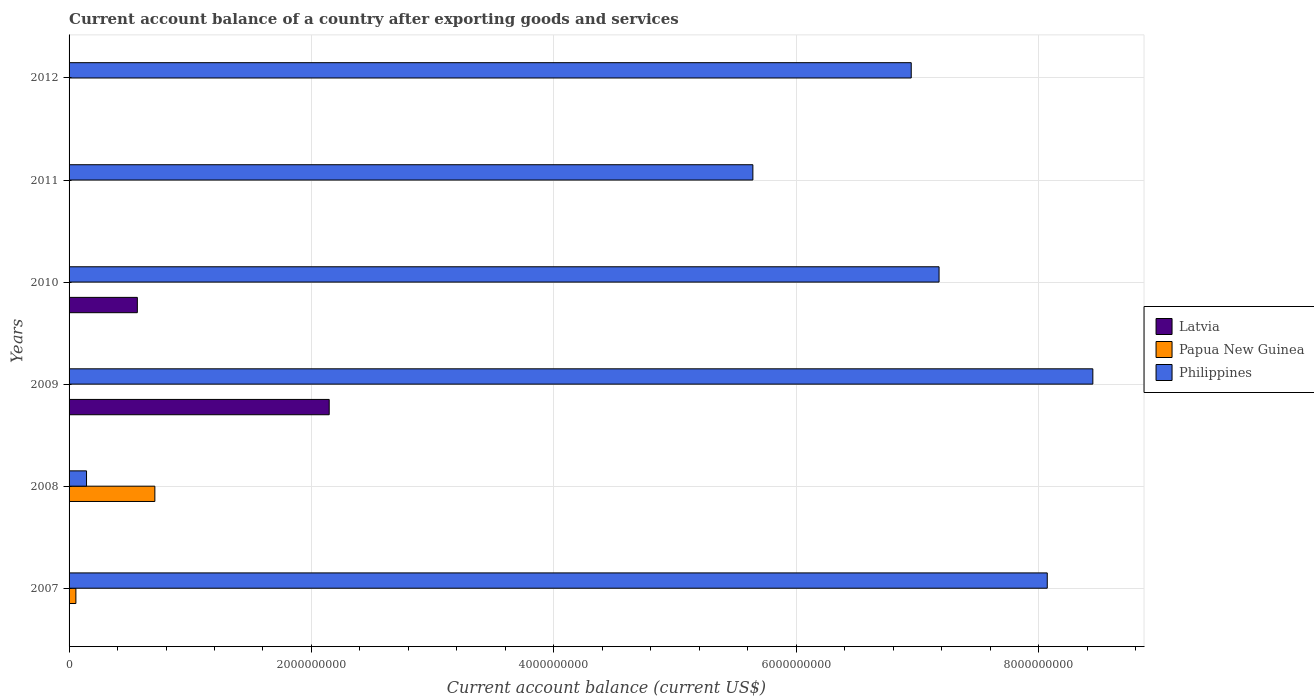Are the number of bars per tick equal to the number of legend labels?
Offer a terse response. No. Are the number of bars on each tick of the Y-axis equal?
Make the answer very short. No. How many bars are there on the 1st tick from the top?
Ensure brevity in your answer.  1. What is the label of the 6th group of bars from the top?
Give a very brief answer. 2007. In how many cases, is the number of bars for a given year not equal to the number of legend labels?
Make the answer very short. 6. What is the account balance in Papua New Guinea in 2007?
Offer a terse response. 5.63e+07. Across all years, what is the maximum account balance in Philippines?
Ensure brevity in your answer.  8.45e+09. What is the total account balance in Philippines in the graph?
Give a very brief answer. 3.64e+1. What is the difference between the account balance in Philippines in 2010 and that in 2012?
Your answer should be compact. 2.30e+08. What is the difference between the account balance in Philippines in 2009 and the account balance in Latvia in 2008?
Offer a very short reply. 8.45e+09. What is the average account balance in Latvia per year?
Give a very brief answer. 4.52e+08. In the year 2009, what is the difference between the account balance in Philippines and account balance in Latvia?
Ensure brevity in your answer.  6.30e+09. In how many years, is the account balance in Papua New Guinea greater than 4800000000 US$?
Your response must be concise. 0. What is the ratio of the account balance in Philippines in 2011 to that in 2012?
Your answer should be compact. 0.81. Is the account balance in Philippines in 2010 less than that in 2011?
Ensure brevity in your answer.  No. What is the difference between the highest and the lowest account balance in Latvia?
Your answer should be very brief. 2.15e+09. How many bars are there?
Make the answer very short. 10. Are all the bars in the graph horizontal?
Keep it short and to the point. Yes. What is the difference between two consecutive major ticks on the X-axis?
Ensure brevity in your answer.  2.00e+09. Does the graph contain any zero values?
Keep it short and to the point. Yes. Where does the legend appear in the graph?
Offer a terse response. Center right. How are the legend labels stacked?
Your response must be concise. Vertical. What is the title of the graph?
Make the answer very short. Current account balance of a country after exporting goods and services. Does "Solomon Islands" appear as one of the legend labels in the graph?
Your answer should be very brief. No. What is the label or title of the X-axis?
Provide a succinct answer. Current account balance (current US$). What is the Current account balance (current US$) of Latvia in 2007?
Ensure brevity in your answer.  0. What is the Current account balance (current US$) in Papua New Guinea in 2007?
Your answer should be very brief. 5.63e+07. What is the Current account balance (current US$) in Philippines in 2007?
Your answer should be compact. 8.07e+09. What is the Current account balance (current US$) of Latvia in 2008?
Make the answer very short. 0. What is the Current account balance (current US$) of Papua New Guinea in 2008?
Offer a terse response. 7.08e+08. What is the Current account balance (current US$) of Philippines in 2008?
Ensure brevity in your answer.  1.44e+08. What is the Current account balance (current US$) in Latvia in 2009?
Provide a succinct answer. 2.15e+09. What is the Current account balance (current US$) of Philippines in 2009?
Your answer should be very brief. 8.45e+09. What is the Current account balance (current US$) of Latvia in 2010?
Provide a short and direct response. 5.63e+08. What is the Current account balance (current US$) of Papua New Guinea in 2010?
Give a very brief answer. 0. What is the Current account balance (current US$) in Philippines in 2010?
Provide a succinct answer. 7.18e+09. What is the Current account balance (current US$) of Philippines in 2011?
Your answer should be compact. 5.64e+09. What is the Current account balance (current US$) of Latvia in 2012?
Provide a succinct answer. 0. What is the Current account balance (current US$) of Papua New Guinea in 2012?
Offer a terse response. 0. What is the Current account balance (current US$) in Philippines in 2012?
Give a very brief answer. 6.95e+09. Across all years, what is the maximum Current account balance (current US$) in Latvia?
Your response must be concise. 2.15e+09. Across all years, what is the maximum Current account balance (current US$) of Papua New Guinea?
Your response must be concise. 7.08e+08. Across all years, what is the maximum Current account balance (current US$) in Philippines?
Ensure brevity in your answer.  8.45e+09. Across all years, what is the minimum Current account balance (current US$) in Latvia?
Give a very brief answer. 0. Across all years, what is the minimum Current account balance (current US$) of Papua New Guinea?
Offer a terse response. 0. Across all years, what is the minimum Current account balance (current US$) in Philippines?
Keep it short and to the point. 1.44e+08. What is the total Current account balance (current US$) of Latvia in the graph?
Provide a succinct answer. 2.71e+09. What is the total Current account balance (current US$) in Papua New Guinea in the graph?
Offer a terse response. 7.64e+08. What is the total Current account balance (current US$) of Philippines in the graph?
Ensure brevity in your answer.  3.64e+1. What is the difference between the Current account balance (current US$) in Papua New Guinea in 2007 and that in 2008?
Your answer should be very brief. -6.52e+08. What is the difference between the Current account balance (current US$) in Philippines in 2007 and that in 2008?
Provide a short and direct response. 7.93e+09. What is the difference between the Current account balance (current US$) in Philippines in 2007 and that in 2009?
Your answer should be very brief. -3.76e+08. What is the difference between the Current account balance (current US$) in Philippines in 2007 and that in 2010?
Offer a terse response. 8.93e+08. What is the difference between the Current account balance (current US$) of Philippines in 2007 and that in 2011?
Offer a very short reply. 2.43e+09. What is the difference between the Current account balance (current US$) of Philippines in 2007 and that in 2012?
Provide a succinct answer. 1.12e+09. What is the difference between the Current account balance (current US$) of Philippines in 2008 and that in 2009?
Make the answer very short. -8.30e+09. What is the difference between the Current account balance (current US$) in Philippines in 2008 and that in 2010?
Your response must be concise. -7.04e+09. What is the difference between the Current account balance (current US$) in Philippines in 2008 and that in 2011?
Your response must be concise. -5.50e+09. What is the difference between the Current account balance (current US$) in Philippines in 2008 and that in 2012?
Offer a very short reply. -6.81e+09. What is the difference between the Current account balance (current US$) of Latvia in 2009 and that in 2010?
Offer a very short reply. 1.58e+09. What is the difference between the Current account balance (current US$) in Philippines in 2009 and that in 2010?
Give a very brief answer. 1.27e+09. What is the difference between the Current account balance (current US$) of Philippines in 2009 and that in 2011?
Provide a succinct answer. 2.81e+09. What is the difference between the Current account balance (current US$) in Philippines in 2009 and that in 2012?
Offer a very short reply. 1.50e+09. What is the difference between the Current account balance (current US$) of Philippines in 2010 and that in 2011?
Provide a succinct answer. 1.54e+09. What is the difference between the Current account balance (current US$) in Philippines in 2010 and that in 2012?
Ensure brevity in your answer.  2.30e+08. What is the difference between the Current account balance (current US$) in Philippines in 2011 and that in 2012?
Provide a short and direct response. -1.31e+09. What is the difference between the Current account balance (current US$) in Papua New Guinea in 2007 and the Current account balance (current US$) in Philippines in 2008?
Provide a succinct answer. -8.77e+07. What is the difference between the Current account balance (current US$) in Papua New Guinea in 2007 and the Current account balance (current US$) in Philippines in 2009?
Give a very brief answer. -8.39e+09. What is the difference between the Current account balance (current US$) in Papua New Guinea in 2007 and the Current account balance (current US$) in Philippines in 2010?
Your answer should be compact. -7.12e+09. What is the difference between the Current account balance (current US$) of Papua New Guinea in 2007 and the Current account balance (current US$) of Philippines in 2011?
Make the answer very short. -5.59e+09. What is the difference between the Current account balance (current US$) of Papua New Guinea in 2007 and the Current account balance (current US$) of Philippines in 2012?
Your response must be concise. -6.89e+09. What is the difference between the Current account balance (current US$) in Papua New Guinea in 2008 and the Current account balance (current US$) in Philippines in 2009?
Provide a succinct answer. -7.74e+09. What is the difference between the Current account balance (current US$) of Papua New Guinea in 2008 and the Current account balance (current US$) of Philippines in 2010?
Your response must be concise. -6.47e+09. What is the difference between the Current account balance (current US$) in Papua New Guinea in 2008 and the Current account balance (current US$) in Philippines in 2011?
Your answer should be compact. -4.93e+09. What is the difference between the Current account balance (current US$) in Papua New Guinea in 2008 and the Current account balance (current US$) in Philippines in 2012?
Make the answer very short. -6.24e+09. What is the difference between the Current account balance (current US$) of Latvia in 2009 and the Current account balance (current US$) of Philippines in 2010?
Offer a terse response. -5.03e+09. What is the difference between the Current account balance (current US$) in Latvia in 2009 and the Current account balance (current US$) in Philippines in 2011?
Make the answer very short. -3.50e+09. What is the difference between the Current account balance (current US$) in Latvia in 2009 and the Current account balance (current US$) in Philippines in 2012?
Your answer should be compact. -4.80e+09. What is the difference between the Current account balance (current US$) in Latvia in 2010 and the Current account balance (current US$) in Philippines in 2011?
Your answer should be very brief. -5.08e+09. What is the difference between the Current account balance (current US$) of Latvia in 2010 and the Current account balance (current US$) of Philippines in 2012?
Ensure brevity in your answer.  -6.39e+09. What is the average Current account balance (current US$) of Latvia per year?
Your answer should be compact. 4.52e+08. What is the average Current account balance (current US$) in Papua New Guinea per year?
Ensure brevity in your answer.  1.27e+08. What is the average Current account balance (current US$) in Philippines per year?
Provide a succinct answer. 6.07e+09. In the year 2007, what is the difference between the Current account balance (current US$) of Papua New Guinea and Current account balance (current US$) of Philippines?
Your response must be concise. -8.02e+09. In the year 2008, what is the difference between the Current account balance (current US$) of Papua New Guinea and Current account balance (current US$) of Philippines?
Give a very brief answer. 5.64e+08. In the year 2009, what is the difference between the Current account balance (current US$) of Latvia and Current account balance (current US$) of Philippines?
Your answer should be compact. -6.30e+09. In the year 2010, what is the difference between the Current account balance (current US$) of Latvia and Current account balance (current US$) of Philippines?
Give a very brief answer. -6.62e+09. What is the ratio of the Current account balance (current US$) in Papua New Guinea in 2007 to that in 2008?
Provide a succinct answer. 0.08. What is the ratio of the Current account balance (current US$) of Philippines in 2007 to that in 2008?
Ensure brevity in your answer.  56.05. What is the ratio of the Current account balance (current US$) of Philippines in 2007 to that in 2009?
Your answer should be very brief. 0.96. What is the ratio of the Current account balance (current US$) in Philippines in 2007 to that in 2010?
Provide a succinct answer. 1.12. What is the ratio of the Current account balance (current US$) of Philippines in 2007 to that in 2011?
Ensure brevity in your answer.  1.43. What is the ratio of the Current account balance (current US$) in Philippines in 2007 to that in 2012?
Give a very brief answer. 1.16. What is the ratio of the Current account balance (current US$) of Philippines in 2008 to that in 2009?
Ensure brevity in your answer.  0.02. What is the ratio of the Current account balance (current US$) of Philippines in 2008 to that in 2010?
Keep it short and to the point. 0.02. What is the ratio of the Current account balance (current US$) of Philippines in 2008 to that in 2011?
Ensure brevity in your answer.  0.03. What is the ratio of the Current account balance (current US$) in Philippines in 2008 to that in 2012?
Offer a very short reply. 0.02. What is the ratio of the Current account balance (current US$) in Latvia in 2009 to that in 2010?
Ensure brevity in your answer.  3.81. What is the ratio of the Current account balance (current US$) of Philippines in 2009 to that in 2010?
Make the answer very short. 1.18. What is the ratio of the Current account balance (current US$) in Philippines in 2009 to that in 2011?
Keep it short and to the point. 1.5. What is the ratio of the Current account balance (current US$) of Philippines in 2009 to that in 2012?
Offer a very short reply. 1.22. What is the ratio of the Current account balance (current US$) in Philippines in 2010 to that in 2011?
Your response must be concise. 1.27. What is the ratio of the Current account balance (current US$) in Philippines in 2010 to that in 2012?
Your answer should be very brief. 1.03. What is the ratio of the Current account balance (current US$) of Philippines in 2011 to that in 2012?
Your answer should be compact. 0.81. What is the difference between the highest and the second highest Current account balance (current US$) of Philippines?
Give a very brief answer. 3.76e+08. What is the difference between the highest and the lowest Current account balance (current US$) of Latvia?
Provide a short and direct response. 2.15e+09. What is the difference between the highest and the lowest Current account balance (current US$) in Papua New Guinea?
Your answer should be very brief. 7.08e+08. What is the difference between the highest and the lowest Current account balance (current US$) in Philippines?
Keep it short and to the point. 8.30e+09. 